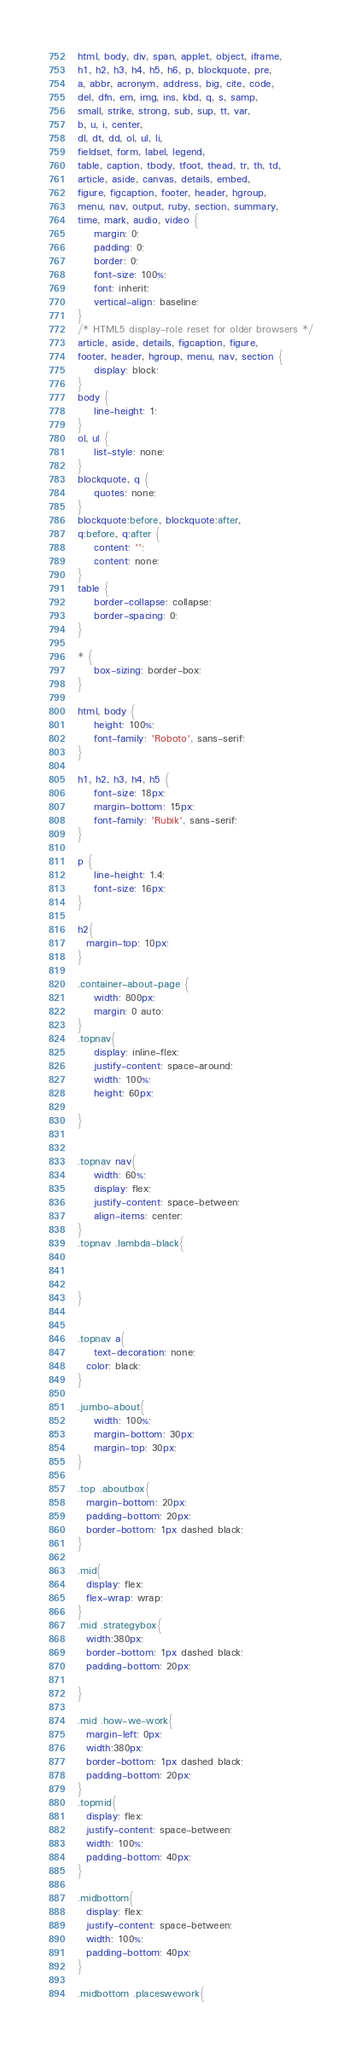<code> <loc_0><loc_0><loc_500><loc_500><_CSS_>html, body, div, span, applet, object, iframe,
h1, h2, h3, h4, h5, h6, p, blockquote, pre,
a, abbr, acronym, address, big, cite, code,
del, dfn, em, img, ins, kbd, q, s, samp,
small, strike, strong, sub, sup, tt, var,
b, u, i, center,
dl, dt, dd, ol, ul, li,
fieldset, form, label, legend,
table, caption, tbody, tfoot, thead, tr, th, td,
article, aside, canvas, details, embed,
figure, figcaption, footer, header, hgroup,
menu, nav, output, ruby, section, summary,
time, mark, audio, video {
	margin: 0;
	padding: 0;
	border: 0;
	font-size: 100%;
	font: inherit;
	vertical-align: baseline;
}
/* HTML5 display-role reset for older browsers */
article, aside, details, figcaption, figure,
footer, header, hgroup, menu, nav, section {
	display: block;
}
body {
	line-height: 1;
}
ol, ul {
	list-style: none;
}
blockquote, q {
	quotes: none;
}
blockquote:before, blockquote:after,
q:before, q:after {
	content: '';
	content: none;
}
table {
	border-collapse: collapse;
	border-spacing: 0;
}

* {
    box-sizing: border-box;
}

html, body {
    height: 100%;
    font-family: 'Roboto', sans-serif;
}

h1, h2, h3, h4, h5 {
    font-size: 18px;
    margin-bottom: 15px;
    font-family: 'Rubik', sans-serif;
}

p {
    line-height: 1.4;
    font-size: 16px;
}

h2{
  margin-top: 10px;
}

.container-about-page {
    width: 800px;
    margin: 0 auto;
}
.topnav{
	display: inline-flex;
	justify-content: space-around;
	width: 100%;
	height: 60px;

}


.topnav nav{
	width: 60%;
	display: flex;
	justify-content: space-between;
	align-items: center;
}
.topnav .lambda-black{



}


.topnav a{
	text-decoration: none;
  color: black;
}

.jumbo-about{
	width: 100%;
	margin-bottom: 30px;
	margin-top: 30px;
}

.top .aboutbox{
  margin-bottom: 20px;
  padding-bottom: 20px;
  border-bottom: 1px dashed black;
}

.mid{
  display: flex;
  flex-wrap: wrap;
}
.mid .strategybox{
  width:380px;
  border-bottom: 1px dashed black;
  padding-bottom: 20px;

}

.mid .how-we-work{
  margin-left: 0px;
  width:380px;
  border-bottom: 1px dashed black;
  padding-bottom: 20px;
}
.topmid{
  display: flex;
  justify-content: space-between;
  width: 100%;
  padding-bottom: 40px;
}

.midbottom{
  display: flex;
  justify-content: space-between;
  width: 100%;
  padding-bottom: 40px;
}

.midbottom .placeswework{</code> 